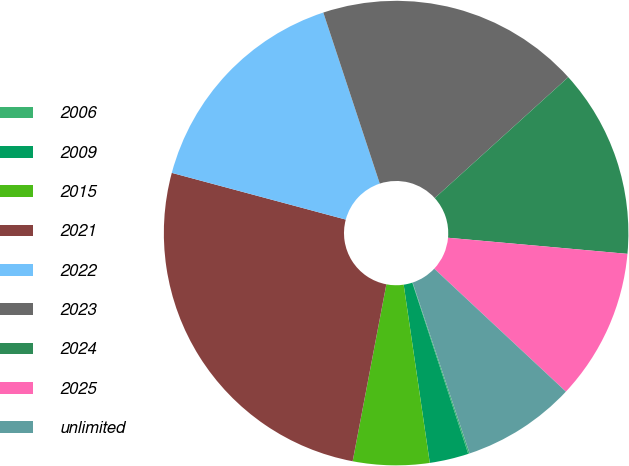<chart> <loc_0><loc_0><loc_500><loc_500><pie_chart><fcel>2006<fcel>2009<fcel>2015<fcel>2021<fcel>2022<fcel>2023<fcel>2024<fcel>2025<fcel>unlimited<nl><fcel>0.1%<fcel>2.71%<fcel>5.31%<fcel>26.18%<fcel>15.75%<fcel>18.36%<fcel>13.14%<fcel>10.53%<fcel>7.92%<nl></chart> 